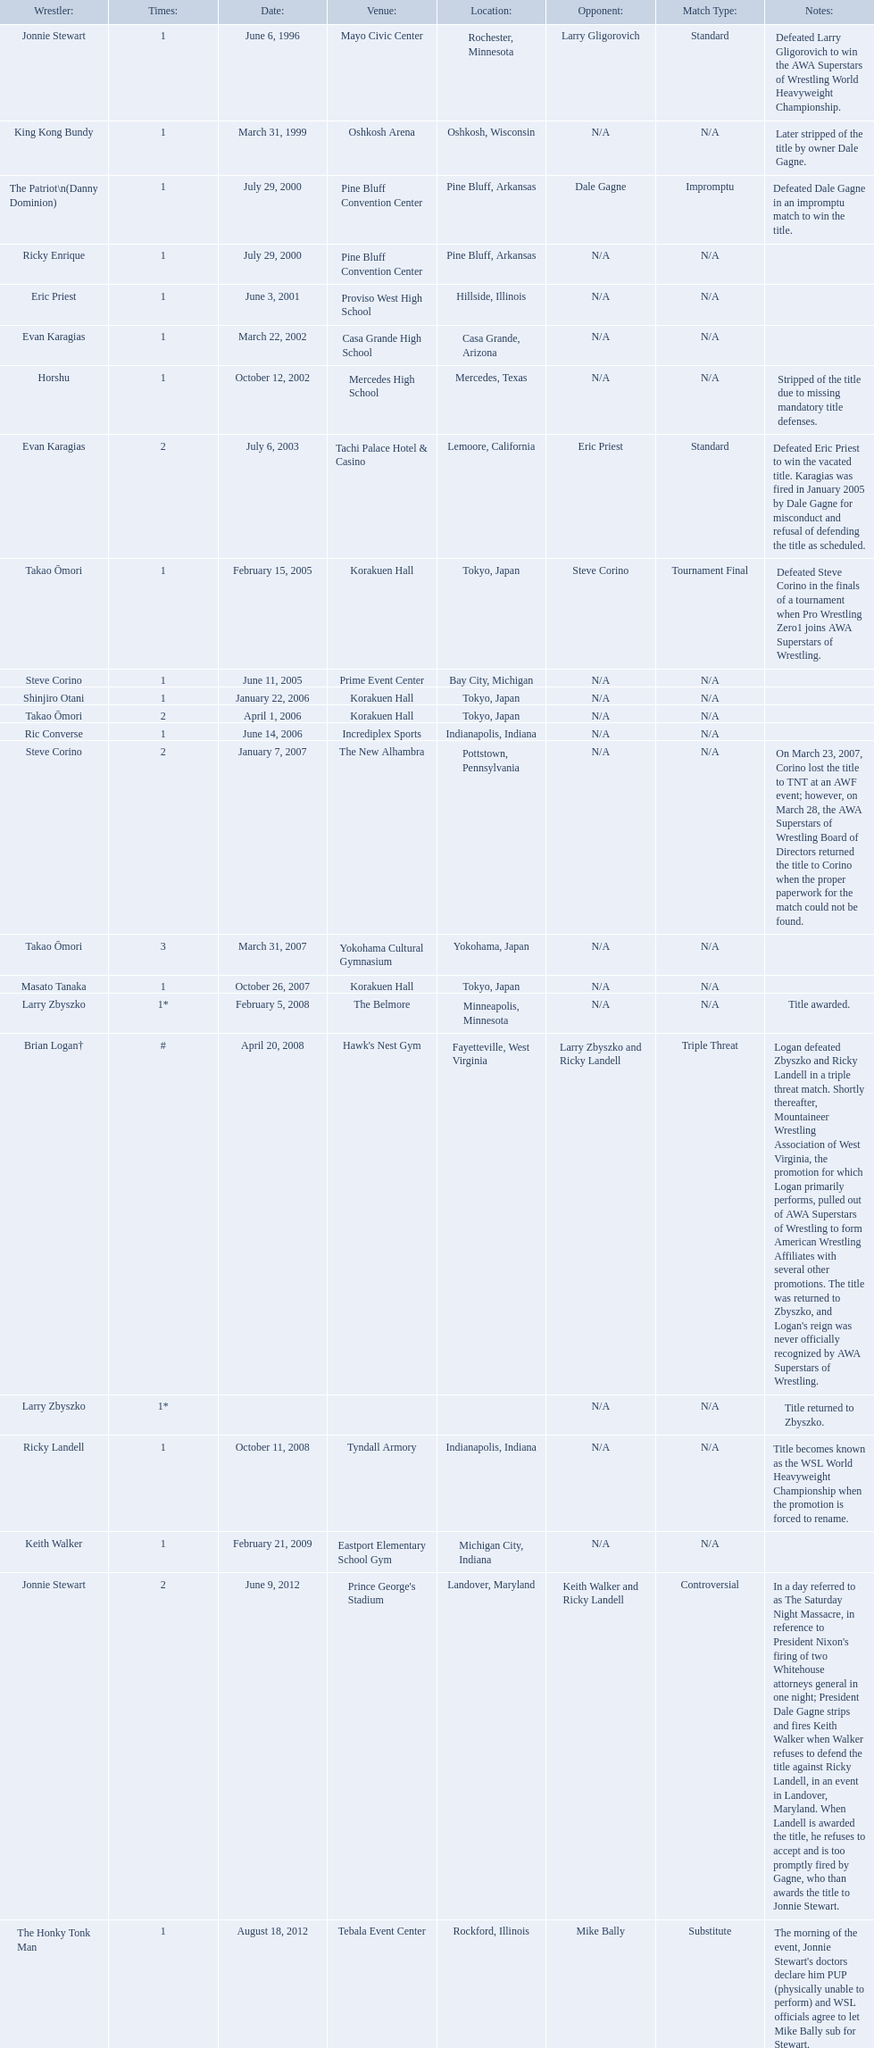Who are the wrestlers? Jonnie Stewart, Rochester, Minnesota, King Kong Bundy, Oshkosh, Wisconsin, The Patriot\n(Danny Dominion), Pine Bluff, Arkansas, Ricky Enrique, Pine Bluff, Arkansas, Eric Priest, Hillside, Illinois, Evan Karagias, Casa Grande, Arizona, Horshu, Mercedes, Texas, Evan Karagias, Lemoore, California, Takao Ōmori, Tokyo, Japan, Steve Corino, Bay City, Michigan, Shinjiro Otani, Tokyo, Japan, Takao Ōmori, Tokyo, Japan, Ric Converse, Indianapolis, Indiana, Steve Corino, Pottstown, Pennsylvania, Takao Ōmori, Yokohama, Japan, Masato Tanaka, Tokyo, Japan, Larry Zbyszko, Minneapolis, Minnesota, Brian Logan†, Fayetteville, West Virginia, Larry Zbyszko, , Ricky Landell, Indianapolis, Indiana, Keith Walker, Michigan City, Indiana, Jonnie Stewart, Landover, Maryland, The Honky Tonk Man, Rockford, Illinois. Who was from texas? Horshu, Mercedes, Texas. Who is he? Horshu. 